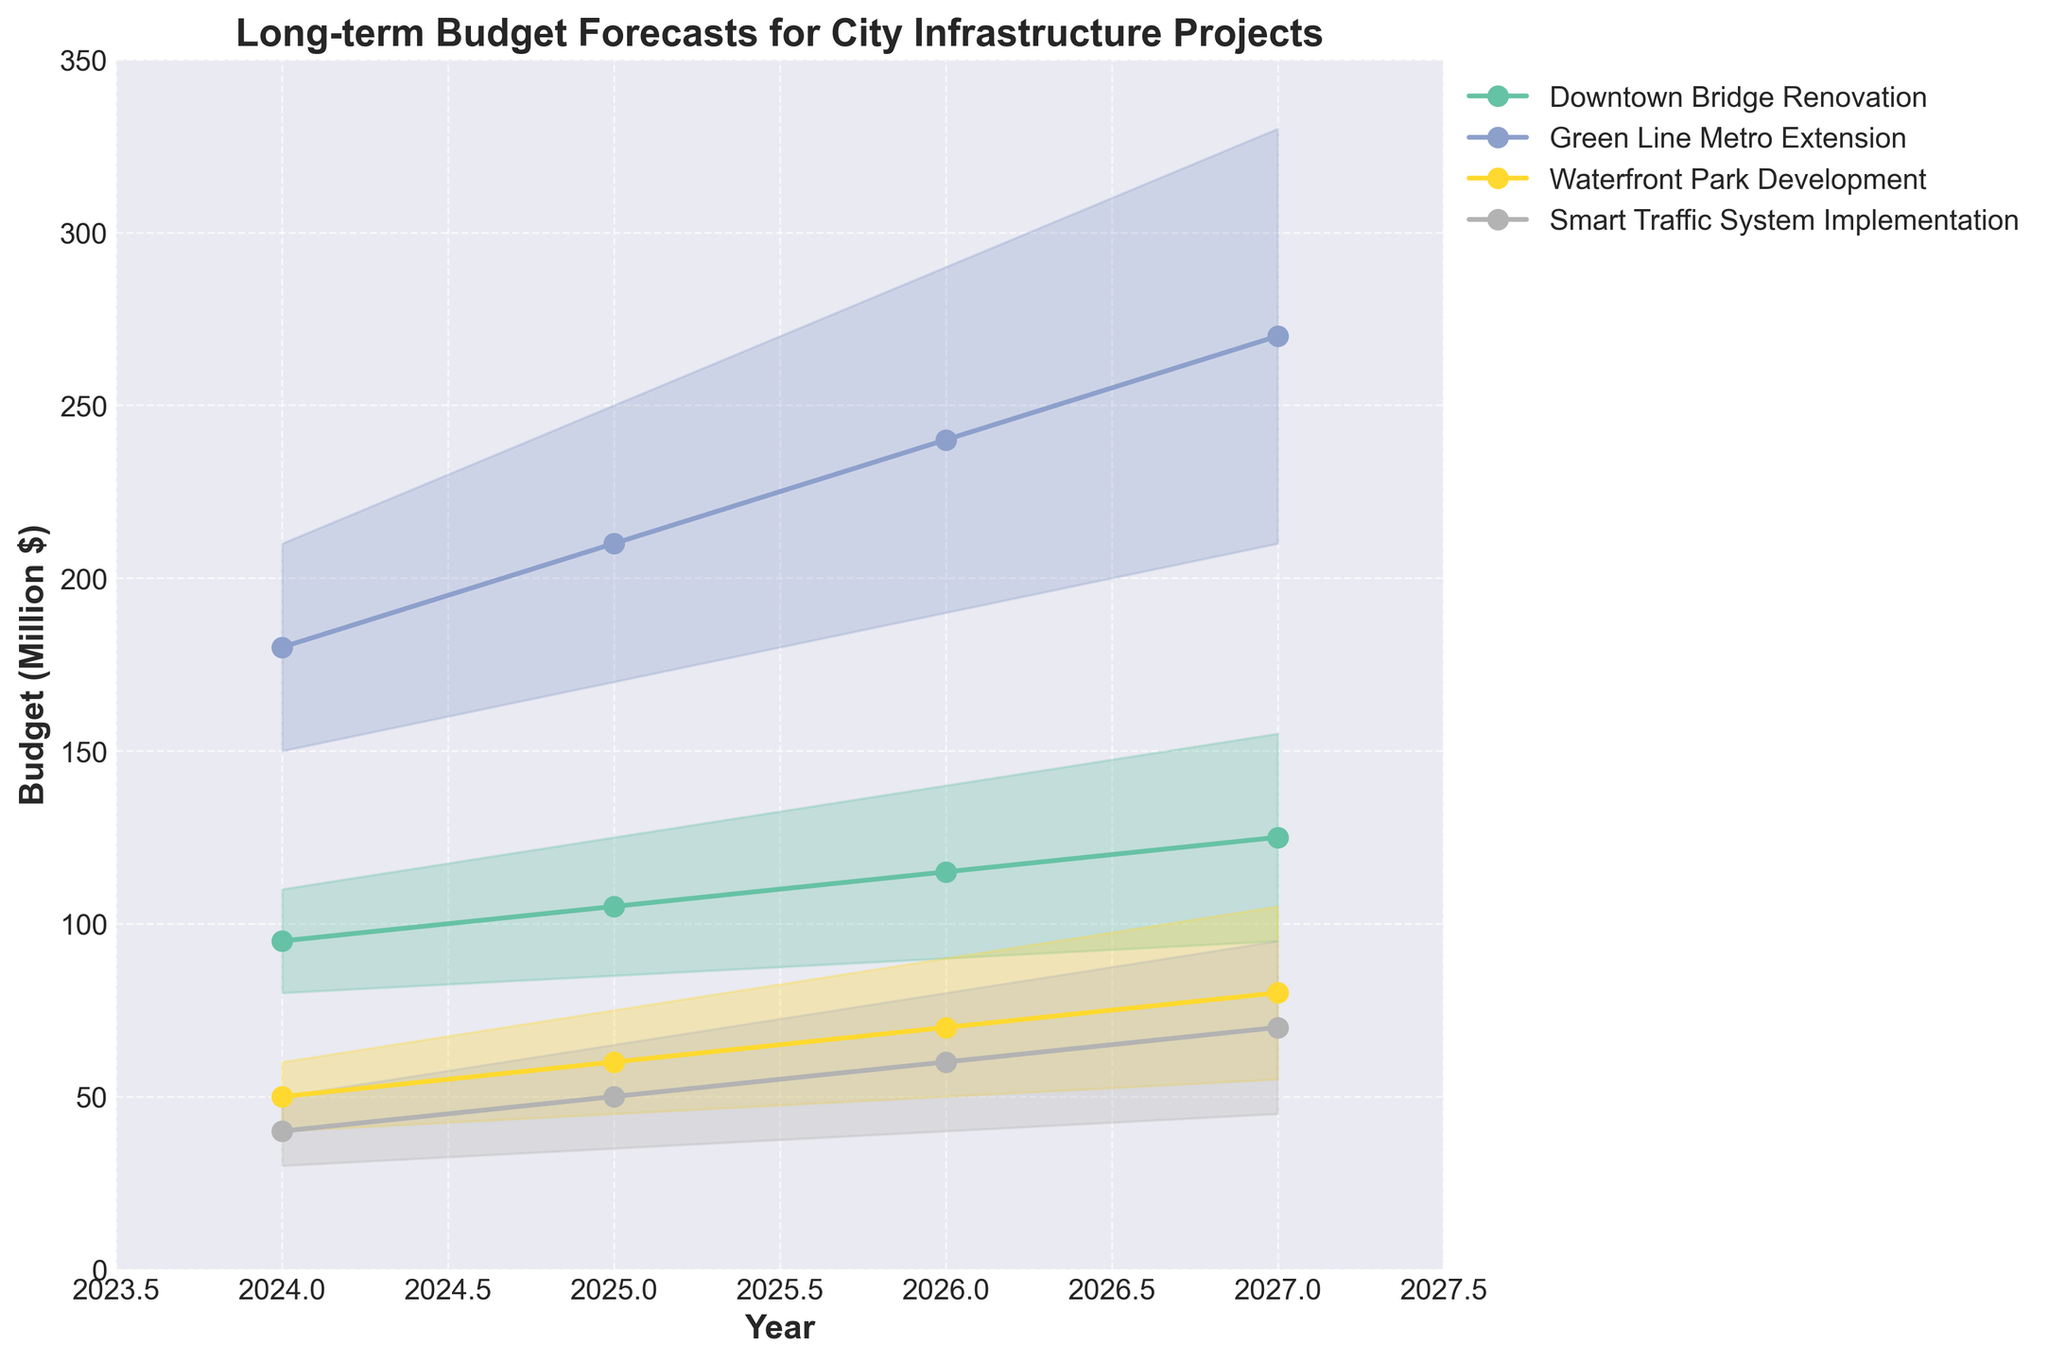What's the title of the chart? The title is located at the top of the chart, and it provides a summary of what the chart represents. It reads: "Long-term Budget Forecasts for City Infrastructure Projects".
Answer: Long-term Budget Forecasts for City Infrastructure Projects In what year is the median budget forecast for the Green Line Metro Extension the highest? To determine this, locate the median values for the Green Line Metro Extension for each year on the chart and compare them. The highest median value is at the highest point on the Green Line Metro Extension's median line.
Answer: 2027 What is the range of budget forecasts for the Downtown Bridge Renovation in 2026? The range can be found by identifying the low confidence interval (CI) and high CI for the Downtown Bridge Renovation in 2026. Subtract the low CI (90) from the high CI (140).
Answer: 50 Which project has the lowest forecasted median budget in 2024? To answer this, find the median values for all projects in 2024 and compare them. The project with the smallest median value in 2024 will have the lowest forecasted median.
Answer: Smart Traffic System Implementation How much does the median budget forecast for the Waterfront Park Development increase from 2024 to 2027? Identify the median budget forecasts for the Waterfront Park Development in 2024 and 2027. Subtract the 2024 median (50) from the 2027 median (80).
Answer: 30 In 2025, which project has the largest variance between its low and high confidence intervals? To find this, calculate the variance for each project in 2025 by subtracting the low CI from the high CI. Compare these variances, and the largest difference will indicate the project with the largest variance.
Answer: Green Line Metro Extension How does the confidence interval range for the Smart Traffic System Implementation change from 2024 to 2027? Calculate the confidence interval ranges for the Smart Traffic System Implementation for 2024 and 2027 by subtracting the low CI from the high CI. Compare the ranges: 2024 (50-30=20), 2027 (95-45=50).
Answer: It increases by 30 Which project shows the most significant increase in its median budget forecast from 2024 to 2027? For each project, subtract the 2024 median value from the 2027 median value and compare these increases. The project with the highest increase is the one with the largest difference.
Answer: Green Line Metro Extension 